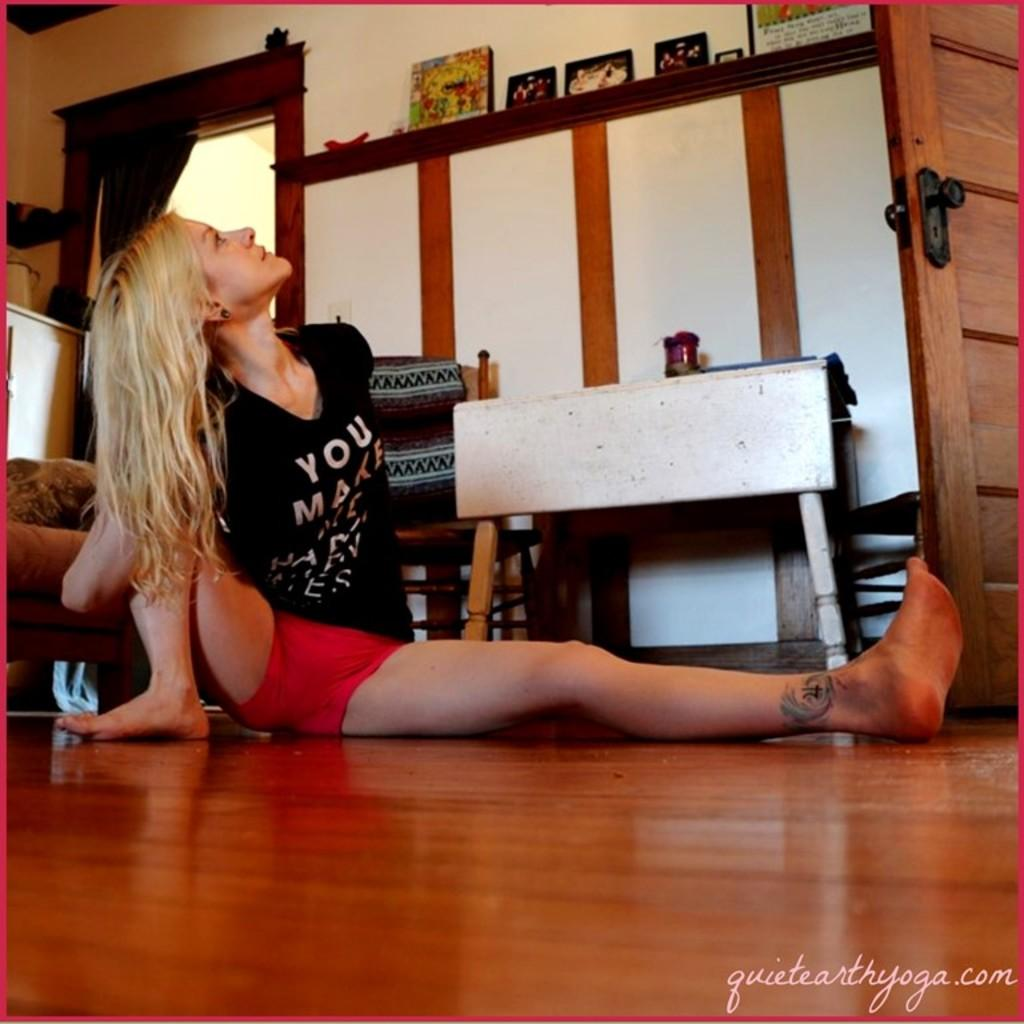<image>
Summarize the visual content of the image. The woman stretching on the floor has a T-shirt that reads "YOU MAKE." 